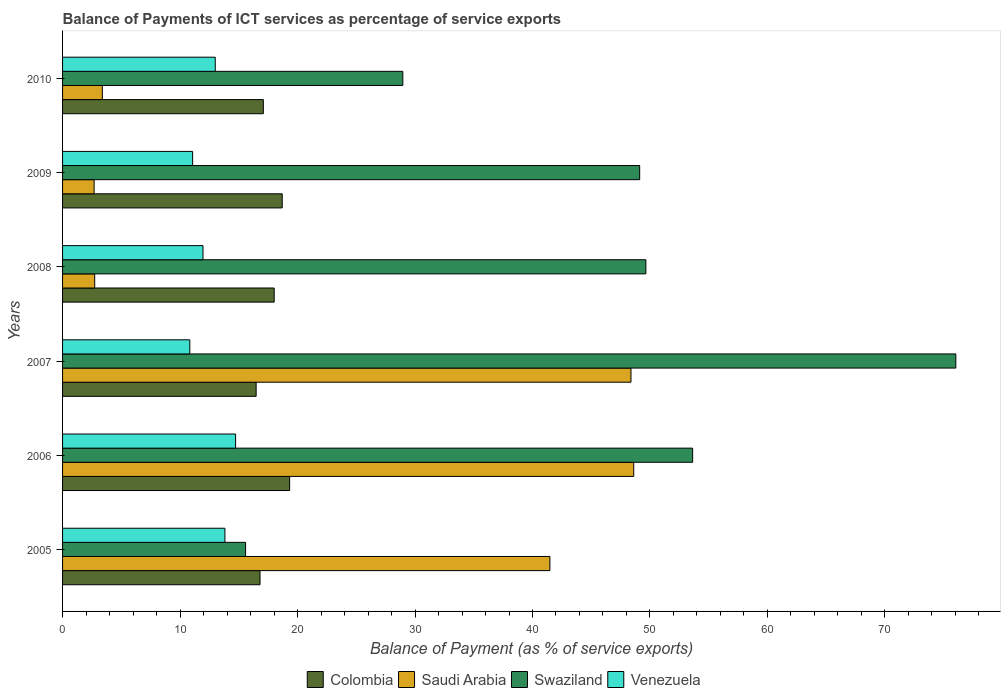How many bars are there on the 2nd tick from the bottom?
Make the answer very short. 4. In how many cases, is the number of bars for a given year not equal to the number of legend labels?
Ensure brevity in your answer.  0. What is the balance of payments of ICT services in Venezuela in 2008?
Offer a terse response. 11.95. Across all years, what is the maximum balance of payments of ICT services in Venezuela?
Keep it short and to the point. 14.73. Across all years, what is the minimum balance of payments of ICT services in Saudi Arabia?
Your answer should be compact. 2.68. What is the total balance of payments of ICT services in Saudi Arabia in the graph?
Give a very brief answer. 147.29. What is the difference between the balance of payments of ICT services in Swaziland in 2008 and that in 2009?
Your answer should be compact. 0.53. What is the difference between the balance of payments of ICT services in Venezuela in 2006 and the balance of payments of ICT services in Swaziland in 2005?
Your response must be concise. -0.85. What is the average balance of payments of ICT services in Swaziland per year?
Make the answer very short. 45.5. In the year 2010, what is the difference between the balance of payments of ICT services in Saudi Arabia and balance of payments of ICT services in Venezuela?
Your response must be concise. -9.61. In how many years, is the balance of payments of ICT services in Saudi Arabia greater than 76 %?
Keep it short and to the point. 0. What is the ratio of the balance of payments of ICT services in Swaziland in 2008 to that in 2010?
Your response must be concise. 1.71. Is the difference between the balance of payments of ICT services in Saudi Arabia in 2005 and 2010 greater than the difference between the balance of payments of ICT services in Venezuela in 2005 and 2010?
Your response must be concise. Yes. What is the difference between the highest and the second highest balance of payments of ICT services in Colombia?
Provide a succinct answer. 0.63. What is the difference between the highest and the lowest balance of payments of ICT services in Colombia?
Keep it short and to the point. 2.85. Is it the case that in every year, the sum of the balance of payments of ICT services in Swaziland and balance of payments of ICT services in Venezuela is greater than the sum of balance of payments of ICT services in Colombia and balance of payments of ICT services in Saudi Arabia?
Provide a short and direct response. Yes. What does the 2nd bar from the top in 2008 represents?
Your answer should be very brief. Swaziland. What does the 3rd bar from the bottom in 2010 represents?
Offer a terse response. Swaziland. How many bars are there?
Make the answer very short. 24. Are all the bars in the graph horizontal?
Your answer should be compact. Yes. What is the difference between two consecutive major ticks on the X-axis?
Your response must be concise. 10. Are the values on the major ticks of X-axis written in scientific E-notation?
Provide a succinct answer. No. How are the legend labels stacked?
Your answer should be very brief. Horizontal. What is the title of the graph?
Offer a terse response. Balance of Payments of ICT services as percentage of service exports. Does "Vietnam" appear as one of the legend labels in the graph?
Keep it short and to the point. No. What is the label or title of the X-axis?
Offer a very short reply. Balance of Payment (as % of service exports). What is the label or title of the Y-axis?
Keep it short and to the point. Years. What is the Balance of Payment (as % of service exports) in Colombia in 2005?
Offer a terse response. 16.81. What is the Balance of Payment (as % of service exports) of Saudi Arabia in 2005?
Your answer should be very brief. 41.48. What is the Balance of Payment (as % of service exports) in Swaziland in 2005?
Keep it short and to the point. 15.58. What is the Balance of Payment (as % of service exports) in Venezuela in 2005?
Your answer should be very brief. 13.82. What is the Balance of Payment (as % of service exports) of Colombia in 2006?
Your answer should be very brief. 19.33. What is the Balance of Payment (as % of service exports) of Saudi Arabia in 2006?
Offer a terse response. 48.62. What is the Balance of Payment (as % of service exports) in Swaziland in 2006?
Give a very brief answer. 53.63. What is the Balance of Payment (as % of service exports) in Venezuela in 2006?
Keep it short and to the point. 14.73. What is the Balance of Payment (as % of service exports) of Colombia in 2007?
Give a very brief answer. 16.48. What is the Balance of Payment (as % of service exports) of Saudi Arabia in 2007?
Provide a succinct answer. 48.38. What is the Balance of Payment (as % of service exports) of Swaziland in 2007?
Make the answer very short. 76.03. What is the Balance of Payment (as % of service exports) of Venezuela in 2007?
Make the answer very short. 10.83. What is the Balance of Payment (as % of service exports) of Colombia in 2008?
Your answer should be compact. 18.01. What is the Balance of Payment (as % of service exports) of Saudi Arabia in 2008?
Ensure brevity in your answer.  2.73. What is the Balance of Payment (as % of service exports) of Swaziland in 2008?
Ensure brevity in your answer.  49.65. What is the Balance of Payment (as % of service exports) of Venezuela in 2008?
Provide a succinct answer. 11.95. What is the Balance of Payment (as % of service exports) in Colombia in 2009?
Your response must be concise. 18.7. What is the Balance of Payment (as % of service exports) of Saudi Arabia in 2009?
Ensure brevity in your answer.  2.68. What is the Balance of Payment (as % of service exports) in Swaziland in 2009?
Give a very brief answer. 49.12. What is the Balance of Payment (as % of service exports) of Venezuela in 2009?
Make the answer very short. 11.07. What is the Balance of Payment (as % of service exports) in Colombia in 2010?
Provide a succinct answer. 17.09. What is the Balance of Payment (as % of service exports) in Saudi Arabia in 2010?
Provide a short and direct response. 3.39. What is the Balance of Payment (as % of service exports) in Swaziland in 2010?
Your response must be concise. 28.96. What is the Balance of Payment (as % of service exports) in Venezuela in 2010?
Keep it short and to the point. 13. Across all years, what is the maximum Balance of Payment (as % of service exports) of Colombia?
Provide a succinct answer. 19.33. Across all years, what is the maximum Balance of Payment (as % of service exports) of Saudi Arabia?
Provide a short and direct response. 48.62. Across all years, what is the maximum Balance of Payment (as % of service exports) in Swaziland?
Offer a very short reply. 76.03. Across all years, what is the maximum Balance of Payment (as % of service exports) of Venezuela?
Provide a succinct answer. 14.73. Across all years, what is the minimum Balance of Payment (as % of service exports) of Colombia?
Your answer should be very brief. 16.48. Across all years, what is the minimum Balance of Payment (as % of service exports) of Saudi Arabia?
Give a very brief answer. 2.68. Across all years, what is the minimum Balance of Payment (as % of service exports) of Swaziland?
Your response must be concise. 15.58. Across all years, what is the minimum Balance of Payment (as % of service exports) of Venezuela?
Your answer should be very brief. 10.83. What is the total Balance of Payment (as % of service exports) in Colombia in the graph?
Offer a terse response. 106.41. What is the total Balance of Payment (as % of service exports) in Saudi Arabia in the graph?
Keep it short and to the point. 147.29. What is the total Balance of Payment (as % of service exports) in Swaziland in the graph?
Ensure brevity in your answer.  272.98. What is the total Balance of Payment (as % of service exports) in Venezuela in the graph?
Your response must be concise. 75.4. What is the difference between the Balance of Payment (as % of service exports) of Colombia in 2005 and that in 2006?
Provide a short and direct response. -2.52. What is the difference between the Balance of Payment (as % of service exports) in Saudi Arabia in 2005 and that in 2006?
Your response must be concise. -7.14. What is the difference between the Balance of Payment (as % of service exports) of Swaziland in 2005 and that in 2006?
Offer a terse response. -38.05. What is the difference between the Balance of Payment (as % of service exports) of Venezuela in 2005 and that in 2006?
Your answer should be compact. -0.91. What is the difference between the Balance of Payment (as % of service exports) of Colombia in 2005 and that in 2007?
Your answer should be very brief. 0.33. What is the difference between the Balance of Payment (as % of service exports) of Saudi Arabia in 2005 and that in 2007?
Provide a succinct answer. -6.9. What is the difference between the Balance of Payment (as % of service exports) of Swaziland in 2005 and that in 2007?
Your answer should be very brief. -60.46. What is the difference between the Balance of Payment (as % of service exports) in Venezuela in 2005 and that in 2007?
Your response must be concise. 2.99. What is the difference between the Balance of Payment (as % of service exports) of Colombia in 2005 and that in 2008?
Ensure brevity in your answer.  -1.21. What is the difference between the Balance of Payment (as % of service exports) of Saudi Arabia in 2005 and that in 2008?
Ensure brevity in your answer.  38.75. What is the difference between the Balance of Payment (as % of service exports) of Swaziland in 2005 and that in 2008?
Make the answer very short. -34.07. What is the difference between the Balance of Payment (as % of service exports) of Venezuela in 2005 and that in 2008?
Provide a succinct answer. 1.86. What is the difference between the Balance of Payment (as % of service exports) of Colombia in 2005 and that in 2009?
Offer a terse response. -1.89. What is the difference between the Balance of Payment (as % of service exports) in Saudi Arabia in 2005 and that in 2009?
Keep it short and to the point. 38.8. What is the difference between the Balance of Payment (as % of service exports) of Swaziland in 2005 and that in 2009?
Keep it short and to the point. -33.55. What is the difference between the Balance of Payment (as % of service exports) in Venezuela in 2005 and that in 2009?
Your response must be concise. 2.75. What is the difference between the Balance of Payment (as % of service exports) of Colombia in 2005 and that in 2010?
Provide a succinct answer. -0.28. What is the difference between the Balance of Payment (as % of service exports) in Saudi Arabia in 2005 and that in 2010?
Provide a short and direct response. 38.1. What is the difference between the Balance of Payment (as % of service exports) in Swaziland in 2005 and that in 2010?
Provide a short and direct response. -13.38. What is the difference between the Balance of Payment (as % of service exports) in Venezuela in 2005 and that in 2010?
Your answer should be very brief. 0.82. What is the difference between the Balance of Payment (as % of service exports) of Colombia in 2006 and that in 2007?
Your answer should be very brief. 2.85. What is the difference between the Balance of Payment (as % of service exports) of Saudi Arabia in 2006 and that in 2007?
Offer a terse response. 0.24. What is the difference between the Balance of Payment (as % of service exports) of Swaziland in 2006 and that in 2007?
Ensure brevity in your answer.  -22.4. What is the difference between the Balance of Payment (as % of service exports) in Venezuela in 2006 and that in 2007?
Provide a short and direct response. 3.9. What is the difference between the Balance of Payment (as % of service exports) of Colombia in 2006 and that in 2008?
Provide a short and direct response. 1.32. What is the difference between the Balance of Payment (as % of service exports) in Saudi Arabia in 2006 and that in 2008?
Keep it short and to the point. 45.88. What is the difference between the Balance of Payment (as % of service exports) in Swaziland in 2006 and that in 2008?
Your answer should be compact. 3.98. What is the difference between the Balance of Payment (as % of service exports) of Venezuela in 2006 and that in 2008?
Give a very brief answer. 2.77. What is the difference between the Balance of Payment (as % of service exports) of Colombia in 2006 and that in 2009?
Provide a succinct answer. 0.63. What is the difference between the Balance of Payment (as % of service exports) of Saudi Arabia in 2006 and that in 2009?
Offer a very short reply. 45.93. What is the difference between the Balance of Payment (as % of service exports) of Swaziland in 2006 and that in 2009?
Your answer should be very brief. 4.51. What is the difference between the Balance of Payment (as % of service exports) of Venezuela in 2006 and that in 2009?
Ensure brevity in your answer.  3.66. What is the difference between the Balance of Payment (as % of service exports) in Colombia in 2006 and that in 2010?
Provide a succinct answer. 2.24. What is the difference between the Balance of Payment (as % of service exports) in Saudi Arabia in 2006 and that in 2010?
Make the answer very short. 45.23. What is the difference between the Balance of Payment (as % of service exports) of Swaziland in 2006 and that in 2010?
Make the answer very short. 24.67. What is the difference between the Balance of Payment (as % of service exports) of Venezuela in 2006 and that in 2010?
Keep it short and to the point. 1.73. What is the difference between the Balance of Payment (as % of service exports) of Colombia in 2007 and that in 2008?
Offer a very short reply. -1.54. What is the difference between the Balance of Payment (as % of service exports) of Saudi Arabia in 2007 and that in 2008?
Give a very brief answer. 45.65. What is the difference between the Balance of Payment (as % of service exports) in Swaziland in 2007 and that in 2008?
Provide a succinct answer. 26.38. What is the difference between the Balance of Payment (as % of service exports) of Venezuela in 2007 and that in 2008?
Make the answer very short. -1.12. What is the difference between the Balance of Payment (as % of service exports) in Colombia in 2007 and that in 2009?
Your response must be concise. -2.22. What is the difference between the Balance of Payment (as % of service exports) of Saudi Arabia in 2007 and that in 2009?
Offer a very short reply. 45.7. What is the difference between the Balance of Payment (as % of service exports) of Swaziland in 2007 and that in 2009?
Your answer should be compact. 26.91. What is the difference between the Balance of Payment (as % of service exports) of Venezuela in 2007 and that in 2009?
Your answer should be very brief. -0.24. What is the difference between the Balance of Payment (as % of service exports) in Colombia in 2007 and that in 2010?
Your answer should be compact. -0.61. What is the difference between the Balance of Payment (as % of service exports) of Saudi Arabia in 2007 and that in 2010?
Ensure brevity in your answer.  45. What is the difference between the Balance of Payment (as % of service exports) of Swaziland in 2007 and that in 2010?
Your response must be concise. 47.07. What is the difference between the Balance of Payment (as % of service exports) in Venezuela in 2007 and that in 2010?
Your response must be concise. -2.17. What is the difference between the Balance of Payment (as % of service exports) of Colombia in 2008 and that in 2009?
Keep it short and to the point. -0.68. What is the difference between the Balance of Payment (as % of service exports) of Saudi Arabia in 2008 and that in 2009?
Make the answer very short. 0.05. What is the difference between the Balance of Payment (as % of service exports) in Swaziland in 2008 and that in 2009?
Provide a short and direct response. 0.53. What is the difference between the Balance of Payment (as % of service exports) of Venezuela in 2008 and that in 2009?
Offer a very short reply. 0.88. What is the difference between the Balance of Payment (as % of service exports) in Colombia in 2008 and that in 2010?
Give a very brief answer. 0.93. What is the difference between the Balance of Payment (as % of service exports) in Saudi Arabia in 2008 and that in 2010?
Ensure brevity in your answer.  -0.65. What is the difference between the Balance of Payment (as % of service exports) of Swaziland in 2008 and that in 2010?
Keep it short and to the point. 20.69. What is the difference between the Balance of Payment (as % of service exports) of Venezuela in 2008 and that in 2010?
Make the answer very short. -1.04. What is the difference between the Balance of Payment (as % of service exports) of Colombia in 2009 and that in 2010?
Your answer should be very brief. 1.61. What is the difference between the Balance of Payment (as % of service exports) in Saudi Arabia in 2009 and that in 2010?
Make the answer very short. -0.7. What is the difference between the Balance of Payment (as % of service exports) of Swaziland in 2009 and that in 2010?
Ensure brevity in your answer.  20.16. What is the difference between the Balance of Payment (as % of service exports) of Venezuela in 2009 and that in 2010?
Your response must be concise. -1.93. What is the difference between the Balance of Payment (as % of service exports) in Colombia in 2005 and the Balance of Payment (as % of service exports) in Saudi Arabia in 2006?
Your answer should be compact. -31.81. What is the difference between the Balance of Payment (as % of service exports) of Colombia in 2005 and the Balance of Payment (as % of service exports) of Swaziland in 2006?
Make the answer very short. -36.82. What is the difference between the Balance of Payment (as % of service exports) of Colombia in 2005 and the Balance of Payment (as % of service exports) of Venezuela in 2006?
Make the answer very short. 2.08. What is the difference between the Balance of Payment (as % of service exports) of Saudi Arabia in 2005 and the Balance of Payment (as % of service exports) of Swaziland in 2006?
Give a very brief answer. -12.15. What is the difference between the Balance of Payment (as % of service exports) in Saudi Arabia in 2005 and the Balance of Payment (as % of service exports) in Venezuela in 2006?
Provide a short and direct response. 26.75. What is the difference between the Balance of Payment (as % of service exports) of Colombia in 2005 and the Balance of Payment (as % of service exports) of Saudi Arabia in 2007?
Keep it short and to the point. -31.57. What is the difference between the Balance of Payment (as % of service exports) of Colombia in 2005 and the Balance of Payment (as % of service exports) of Swaziland in 2007?
Keep it short and to the point. -59.23. What is the difference between the Balance of Payment (as % of service exports) of Colombia in 2005 and the Balance of Payment (as % of service exports) of Venezuela in 2007?
Ensure brevity in your answer.  5.98. What is the difference between the Balance of Payment (as % of service exports) of Saudi Arabia in 2005 and the Balance of Payment (as % of service exports) of Swaziland in 2007?
Your answer should be very brief. -34.55. What is the difference between the Balance of Payment (as % of service exports) of Saudi Arabia in 2005 and the Balance of Payment (as % of service exports) of Venezuela in 2007?
Your answer should be very brief. 30.65. What is the difference between the Balance of Payment (as % of service exports) of Swaziland in 2005 and the Balance of Payment (as % of service exports) of Venezuela in 2007?
Your answer should be compact. 4.75. What is the difference between the Balance of Payment (as % of service exports) in Colombia in 2005 and the Balance of Payment (as % of service exports) in Saudi Arabia in 2008?
Your answer should be very brief. 14.07. What is the difference between the Balance of Payment (as % of service exports) of Colombia in 2005 and the Balance of Payment (as % of service exports) of Swaziland in 2008?
Provide a succinct answer. -32.84. What is the difference between the Balance of Payment (as % of service exports) in Colombia in 2005 and the Balance of Payment (as % of service exports) in Venezuela in 2008?
Provide a short and direct response. 4.85. What is the difference between the Balance of Payment (as % of service exports) of Saudi Arabia in 2005 and the Balance of Payment (as % of service exports) of Swaziland in 2008?
Your response must be concise. -8.17. What is the difference between the Balance of Payment (as % of service exports) of Saudi Arabia in 2005 and the Balance of Payment (as % of service exports) of Venezuela in 2008?
Your answer should be compact. 29.53. What is the difference between the Balance of Payment (as % of service exports) in Swaziland in 2005 and the Balance of Payment (as % of service exports) in Venezuela in 2008?
Provide a short and direct response. 3.62. What is the difference between the Balance of Payment (as % of service exports) of Colombia in 2005 and the Balance of Payment (as % of service exports) of Saudi Arabia in 2009?
Provide a short and direct response. 14.12. What is the difference between the Balance of Payment (as % of service exports) of Colombia in 2005 and the Balance of Payment (as % of service exports) of Swaziland in 2009?
Give a very brief answer. -32.32. What is the difference between the Balance of Payment (as % of service exports) of Colombia in 2005 and the Balance of Payment (as % of service exports) of Venezuela in 2009?
Make the answer very short. 5.74. What is the difference between the Balance of Payment (as % of service exports) of Saudi Arabia in 2005 and the Balance of Payment (as % of service exports) of Swaziland in 2009?
Ensure brevity in your answer.  -7.64. What is the difference between the Balance of Payment (as % of service exports) in Saudi Arabia in 2005 and the Balance of Payment (as % of service exports) in Venezuela in 2009?
Your answer should be compact. 30.41. What is the difference between the Balance of Payment (as % of service exports) of Swaziland in 2005 and the Balance of Payment (as % of service exports) of Venezuela in 2009?
Ensure brevity in your answer.  4.51. What is the difference between the Balance of Payment (as % of service exports) in Colombia in 2005 and the Balance of Payment (as % of service exports) in Saudi Arabia in 2010?
Your answer should be very brief. 13.42. What is the difference between the Balance of Payment (as % of service exports) in Colombia in 2005 and the Balance of Payment (as % of service exports) in Swaziland in 2010?
Offer a very short reply. -12.16. What is the difference between the Balance of Payment (as % of service exports) of Colombia in 2005 and the Balance of Payment (as % of service exports) of Venezuela in 2010?
Your response must be concise. 3.81. What is the difference between the Balance of Payment (as % of service exports) in Saudi Arabia in 2005 and the Balance of Payment (as % of service exports) in Swaziland in 2010?
Give a very brief answer. 12.52. What is the difference between the Balance of Payment (as % of service exports) in Saudi Arabia in 2005 and the Balance of Payment (as % of service exports) in Venezuela in 2010?
Your response must be concise. 28.48. What is the difference between the Balance of Payment (as % of service exports) in Swaziland in 2005 and the Balance of Payment (as % of service exports) in Venezuela in 2010?
Offer a terse response. 2.58. What is the difference between the Balance of Payment (as % of service exports) of Colombia in 2006 and the Balance of Payment (as % of service exports) of Saudi Arabia in 2007?
Offer a very short reply. -29.05. What is the difference between the Balance of Payment (as % of service exports) in Colombia in 2006 and the Balance of Payment (as % of service exports) in Swaziland in 2007?
Keep it short and to the point. -56.71. What is the difference between the Balance of Payment (as % of service exports) in Colombia in 2006 and the Balance of Payment (as % of service exports) in Venezuela in 2007?
Offer a terse response. 8.5. What is the difference between the Balance of Payment (as % of service exports) of Saudi Arabia in 2006 and the Balance of Payment (as % of service exports) of Swaziland in 2007?
Your response must be concise. -27.42. What is the difference between the Balance of Payment (as % of service exports) in Saudi Arabia in 2006 and the Balance of Payment (as % of service exports) in Venezuela in 2007?
Your answer should be very brief. 37.79. What is the difference between the Balance of Payment (as % of service exports) of Swaziland in 2006 and the Balance of Payment (as % of service exports) of Venezuela in 2007?
Provide a short and direct response. 42.8. What is the difference between the Balance of Payment (as % of service exports) in Colombia in 2006 and the Balance of Payment (as % of service exports) in Saudi Arabia in 2008?
Make the answer very short. 16.59. What is the difference between the Balance of Payment (as % of service exports) of Colombia in 2006 and the Balance of Payment (as % of service exports) of Swaziland in 2008?
Make the answer very short. -30.32. What is the difference between the Balance of Payment (as % of service exports) of Colombia in 2006 and the Balance of Payment (as % of service exports) of Venezuela in 2008?
Ensure brevity in your answer.  7.37. What is the difference between the Balance of Payment (as % of service exports) in Saudi Arabia in 2006 and the Balance of Payment (as % of service exports) in Swaziland in 2008?
Your response must be concise. -1.03. What is the difference between the Balance of Payment (as % of service exports) of Saudi Arabia in 2006 and the Balance of Payment (as % of service exports) of Venezuela in 2008?
Provide a short and direct response. 36.66. What is the difference between the Balance of Payment (as % of service exports) in Swaziland in 2006 and the Balance of Payment (as % of service exports) in Venezuela in 2008?
Offer a terse response. 41.68. What is the difference between the Balance of Payment (as % of service exports) of Colombia in 2006 and the Balance of Payment (as % of service exports) of Saudi Arabia in 2009?
Your answer should be very brief. 16.64. What is the difference between the Balance of Payment (as % of service exports) of Colombia in 2006 and the Balance of Payment (as % of service exports) of Swaziland in 2009?
Keep it short and to the point. -29.8. What is the difference between the Balance of Payment (as % of service exports) in Colombia in 2006 and the Balance of Payment (as % of service exports) in Venezuela in 2009?
Make the answer very short. 8.26. What is the difference between the Balance of Payment (as % of service exports) of Saudi Arabia in 2006 and the Balance of Payment (as % of service exports) of Swaziland in 2009?
Make the answer very short. -0.51. What is the difference between the Balance of Payment (as % of service exports) of Saudi Arabia in 2006 and the Balance of Payment (as % of service exports) of Venezuela in 2009?
Your answer should be compact. 37.55. What is the difference between the Balance of Payment (as % of service exports) in Swaziland in 2006 and the Balance of Payment (as % of service exports) in Venezuela in 2009?
Offer a terse response. 42.56. What is the difference between the Balance of Payment (as % of service exports) in Colombia in 2006 and the Balance of Payment (as % of service exports) in Saudi Arabia in 2010?
Offer a terse response. 15.94. What is the difference between the Balance of Payment (as % of service exports) in Colombia in 2006 and the Balance of Payment (as % of service exports) in Swaziland in 2010?
Your answer should be very brief. -9.63. What is the difference between the Balance of Payment (as % of service exports) of Colombia in 2006 and the Balance of Payment (as % of service exports) of Venezuela in 2010?
Your answer should be compact. 6.33. What is the difference between the Balance of Payment (as % of service exports) of Saudi Arabia in 2006 and the Balance of Payment (as % of service exports) of Swaziland in 2010?
Ensure brevity in your answer.  19.65. What is the difference between the Balance of Payment (as % of service exports) of Saudi Arabia in 2006 and the Balance of Payment (as % of service exports) of Venezuela in 2010?
Provide a succinct answer. 35.62. What is the difference between the Balance of Payment (as % of service exports) of Swaziland in 2006 and the Balance of Payment (as % of service exports) of Venezuela in 2010?
Keep it short and to the point. 40.63. What is the difference between the Balance of Payment (as % of service exports) of Colombia in 2007 and the Balance of Payment (as % of service exports) of Saudi Arabia in 2008?
Your answer should be compact. 13.74. What is the difference between the Balance of Payment (as % of service exports) in Colombia in 2007 and the Balance of Payment (as % of service exports) in Swaziland in 2008?
Your answer should be compact. -33.17. What is the difference between the Balance of Payment (as % of service exports) in Colombia in 2007 and the Balance of Payment (as % of service exports) in Venezuela in 2008?
Offer a terse response. 4.52. What is the difference between the Balance of Payment (as % of service exports) in Saudi Arabia in 2007 and the Balance of Payment (as % of service exports) in Swaziland in 2008?
Your response must be concise. -1.27. What is the difference between the Balance of Payment (as % of service exports) of Saudi Arabia in 2007 and the Balance of Payment (as % of service exports) of Venezuela in 2008?
Provide a succinct answer. 36.43. What is the difference between the Balance of Payment (as % of service exports) of Swaziland in 2007 and the Balance of Payment (as % of service exports) of Venezuela in 2008?
Provide a short and direct response. 64.08. What is the difference between the Balance of Payment (as % of service exports) of Colombia in 2007 and the Balance of Payment (as % of service exports) of Saudi Arabia in 2009?
Your response must be concise. 13.79. What is the difference between the Balance of Payment (as % of service exports) of Colombia in 2007 and the Balance of Payment (as % of service exports) of Swaziland in 2009?
Provide a short and direct response. -32.65. What is the difference between the Balance of Payment (as % of service exports) of Colombia in 2007 and the Balance of Payment (as % of service exports) of Venezuela in 2009?
Your response must be concise. 5.41. What is the difference between the Balance of Payment (as % of service exports) in Saudi Arabia in 2007 and the Balance of Payment (as % of service exports) in Swaziland in 2009?
Ensure brevity in your answer.  -0.74. What is the difference between the Balance of Payment (as % of service exports) in Saudi Arabia in 2007 and the Balance of Payment (as % of service exports) in Venezuela in 2009?
Your response must be concise. 37.31. What is the difference between the Balance of Payment (as % of service exports) of Swaziland in 2007 and the Balance of Payment (as % of service exports) of Venezuela in 2009?
Provide a short and direct response. 64.96. What is the difference between the Balance of Payment (as % of service exports) of Colombia in 2007 and the Balance of Payment (as % of service exports) of Saudi Arabia in 2010?
Your response must be concise. 13.09. What is the difference between the Balance of Payment (as % of service exports) in Colombia in 2007 and the Balance of Payment (as % of service exports) in Swaziland in 2010?
Your response must be concise. -12.49. What is the difference between the Balance of Payment (as % of service exports) of Colombia in 2007 and the Balance of Payment (as % of service exports) of Venezuela in 2010?
Keep it short and to the point. 3.48. What is the difference between the Balance of Payment (as % of service exports) in Saudi Arabia in 2007 and the Balance of Payment (as % of service exports) in Swaziland in 2010?
Keep it short and to the point. 19.42. What is the difference between the Balance of Payment (as % of service exports) of Saudi Arabia in 2007 and the Balance of Payment (as % of service exports) of Venezuela in 2010?
Provide a short and direct response. 35.39. What is the difference between the Balance of Payment (as % of service exports) in Swaziland in 2007 and the Balance of Payment (as % of service exports) in Venezuela in 2010?
Your response must be concise. 63.04. What is the difference between the Balance of Payment (as % of service exports) in Colombia in 2008 and the Balance of Payment (as % of service exports) in Saudi Arabia in 2009?
Your answer should be compact. 15.33. What is the difference between the Balance of Payment (as % of service exports) in Colombia in 2008 and the Balance of Payment (as % of service exports) in Swaziland in 2009?
Provide a short and direct response. -31.11. What is the difference between the Balance of Payment (as % of service exports) of Colombia in 2008 and the Balance of Payment (as % of service exports) of Venezuela in 2009?
Your answer should be very brief. 6.94. What is the difference between the Balance of Payment (as % of service exports) of Saudi Arabia in 2008 and the Balance of Payment (as % of service exports) of Swaziland in 2009?
Your answer should be very brief. -46.39. What is the difference between the Balance of Payment (as % of service exports) in Saudi Arabia in 2008 and the Balance of Payment (as % of service exports) in Venezuela in 2009?
Your answer should be very brief. -8.34. What is the difference between the Balance of Payment (as % of service exports) in Swaziland in 2008 and the Balance of Payment (as % of service exports) in Venezuela in 2009?
Offer a very short reply. 38.58. What is the difference between the Balance of Payment (as % of service exports) in Colombia in 2008 and the Balance of Payment (as % of service exports) in Saudi Arabia in 2010?
Offer a very short reply. 14.63. What is the difference between the Balance of Payment (as % of service exports) in Colombia in 2008 and the Balance of Payment (as % of service exports) in Swaziland in 2010?
Ensure brevity in your answer.  -10.95. What is the difference between the Balance of Payment (as % of service exports) of Colombia in 2008 and the Balance of Payment (as % of service exports) of Venezuela in 2010?
Make the answer very short. 5.02. What is the difference between the Balance of Payment (as % of service exports) in Saudi Arabia in 2008 and the Balance of Payment (as % of service exports) in Swaziland in 2010?
Your answer should be compact. -26.23. What is the difference between the Balance of Payment (as % of service exports) of Saudi Arabia in 2008 and the Balance of Payment (as % of service exports) of Venezuela in 2010?
Your answer should be compact. -10.26. What is the difference between the Balance of Payment (as % of service exports) of Swaziland in 2008 and the Balance of Payment (as % of service exports) of Venezuela in 2010?
Provide a short and direct response. 36.65. What is the difference between the Balance of Payment (as % of service exports) of Colombia in 2009 and the Balance of Payment (as % of service exports) of Saudi Arabia in 2010?
Ensure brevity in your answer.  15.31. What is the difference between the Balance of Payment (as % of service exports) of Colombia in 2009 and the Balance of Payment (as % of service exports) of Swaziland in 2010?
Offer a terse response. -10.27. What is the difference between the Balance of Payment (as % of service exports) of Colombia in 2009 and the Balance of Payment (as % of service exports) of Venezuela in 2010?
Make the answer very short. 5.7. What is the difference between the Balance of Payment (as % of service exports) of Saudi Arabia in 2009 and the Balance of Payment (as % of service exports) of Swaziland in 2010?
Keep it short and to the point. -26.28. What is the difference between the Balance of Payment (as % of service exports) of Saudi Arabia in 2009 and the Balance of Payment (as % of service exports) of Venezuela in 2010?
Your answer should be very brief. -10.31. What is the difference between the Balance of Payment (as % of service exports) of Swaziland in 2009 and the Balance of Payment (as % of service exports) of Venezuela in 2010?
Make the answer very short. 36.13. What is the average Balance of Payment (as % of service exports) of Colombia per year?
Give a very brief answer. 17.74. What is the average Balance of Payment (as % of service exports) in Saudi Arabia per year?
Give a very brief answer. 24.55. What is the average Balance of Payment (as % of service exports) of Swaziland per year?
Offer a very short reply. 45.5. What is the average Balance of Payment (as % of service exports) in Venezuela per year?
Make the answer very short. 12.57. In the year 2005, what is the difference between the Balance of Payment (as % of service exports) of Colombia and Balance of Payment (as % of service exports) of Saudi Arabia?
Provide a short and direct response. -24.67. In the year 2005, what is the difference between the Balance of Payment (as % of service exports) in Colombia and Balance of Payment (as % of service exports) in Swaziland?
Provide a short and direct response. 1.23. In the year 2005, what is the difference between the Balance of Payment (as % of service exports) in Colombia and Balance of Payment (as % of service exports) in Venezuela?
Your answer should be compact. 2.99. In the year 2005, what is the difference between the Balance of Payment (as % of service exports) in Saudi Arabia and Balance of Payment (as % of service exports) in Swaziland?
Keep it short and to the point. 25.9. In the year 2005, what is the difference between the Balance of Payment (as % of service exports) of Saudi Arabia and Balance of Payment (as % of service exports) of Venezuela?
Provide a succinct answer. 27.66. In the year 2005, what is the difference between the Balance of Payment (as % of service exports) of Swaziland and Balance of Payment (as % of service exports) of Venezuela?
Provide a succinct answer. 1.76. In the year 2006, what is the difference between the Balance of Payment (as % of service exports) in Colombia and Balance of Payment (as % of service exports) in Saudi Arabia?
Provide a short and direct response. -29.29. In the year 2006, what is the difference between the Balance of Payment (as % of service exports) in Colombia and Balance of Payment (as % of service exports) in Swaziland?
Ensure brevity in your answer.  -34.3. In the year 2006, what is the difference between the Balance of Payment (as % of service exports) in Saudi Arabia and Balance of Payment (as % of service exports) in Swaziland?
Provide a succinct answer. -5.01. In the year 2006, what is the difference between the Balance of Payment (as % of service exports) of Saudi Arabia and Balance of Payment (as % of service exports) of Venezuela?
Offer a terse response. 33.89. In the year 2006, what is the difference between the Balance of Payment (as % of service exports) of Swaziland and Balance of Payment (as % of service exports) of Venezuela?
Your answer should be very brief. 38.9. In the year 2007, what is the difference between the Balance of Payment (as % of service exports) of Colombia and Balance of Payment (as % of service exports) of Saudi Arabia?
Provide a short and direct response. -31.9. In the year 2007, what is the difference between the Balance of Payment (as % of service exports) in Colombia and Balance of Payment (as % of service exports) in Swaziland?
Your answer should be compact. -59.56. In the year 2007, what is the difference between the Balance of Payment (as % of service exports) of Colombia and Balance of Payment (as % of service exports) of Venezuela?
Your answer should be very brief. 5.65. In the year 2007, what is the difference between the Balance of Payment (as % of service exports) in Saudi Arabia and Balance of Payment (as % of service exports) in Swaziland?
Provide a succinct answer. -27.65. In the year 2007, what is the difference between the Balance of Payment (as % of service exports) in Saudi Arabia and Balance of Payment (as % of service exports) in Venezuela?
Your response must be concise. 37.55. In the year 2007, what is the difference between the Balance of Payment (as % of service exports) in Swaziland and Balance of Payment (as % of service exports) in Venezuela?
Provide a succinct answer. 65.2. In the year 2008, what is the difference between the Balance of Payment (as % of service exports) of Colombia and Balance of Payment (as % of service exports) of Saudi Arabia?
Give a very brief answer. 15.28. In the year 2008, what is the difference between the Balance of Payment (as % of service exports) in Colombia and Balance of Payment (as % of service exports) in Swaziland?
Provide a succinct answer. -31.64. In the year 2008, what is the difference between the Balance of Payment (as % of service exports) of Colombia and Balance of Payment (as % of service exports) of Venezuela?
Ensure brevity in your answer.  6.06. In the year 2008, what is the difference between the Balance of Payment (as % of service exports) in Saudi Arabia and Balance of Payment (as % of service exports) in Swaziland?
Provide a succinct answer. -46.92. In the year 2008, what is the difference between the Balance of Payment (as % of service exports) in Saudi Arabia and Balance of Payment (as % of service exports) in Venezuela?
Your response must be concise. -9.22. In the year 2008, what is the difference between the Balance of Payment (as % of service exports) in Swaziland and Balance of Payment (as % of service exports) in Venezuela?
Give a very brief answer. 37.7. In the year 2009, what is the difference between the Balance of Payment (as % of service exports) in Colombia and Balance of Payment (as % of service exports) in Saudi Arabia?
Ensure brevity in your answer.  16.01. In the year 2009, what is the difference between the Balance of Payment (as % of service exports) of Colombia and Balance of Payment (as % of service exports) of Swaziland?
Offer a terse response. -30.43. In the year 2009, what is the difference between the Balance of Payment (as % of service exports) of Colombia and Balance of Payment (as % of service exports) of Venezuela?
Ensure brevity in your answer.  7.63. In the year 2009, what is the difference between the Balance of Payment (as % of service exports) in Saudi Arabia and Balance of Payment (as % of service exports) in Swaziland?
Ensure brevity in your answer.  -46.44. In the year 2009, what is the difference between the Balance of Payment (as % of service exports) in Saudi Arabia and Balance of Payment (as % of service exports) in Venezuela?
Keep it short and to the point. -8.39. In the year 2009, what is the difference between the Balance of Payment (as % of service exports) in Swaziland and Balance of Payment (as % of service exports) in Venezuela?
Offer a terse response. 38.05. In the year 2010, what is the difference between the Balance of Payment (as % of service exports) of Colombia and Balance of Payment (as % of service exports) of Saudi Arabia?
Your response must be concise. 13.7. In the year 2010, what is the difference between the Balance of Payment (as % of service exports) in Colombia and Balance of Payment (as % of service exports) in Swaziland?
Ensure brevity in your answer.  -11.87. In the year 2010, what is the difference between the Balance of Payment (as % of service exports) in Colombia and Balance of Payment (as % of service exports) in Venezuela?
Your answer should be compact. 4.09. In the year 2010, what is the difference between the Balance of Payment (as % of service exports) in Saudi Arabia and Balance of Payment (as % of service exports) in Swaziland?
Your answer should be compact. -25.58. In the year 2010, what is the difference between the Balance of Payment (as % of service exports) in Saudi Arabia and Balance of Payment (as % of service exports) in Venezuela?
Your response must be concise. -9.61. In the year 2010, what is the difference between the Balance of Payment (as % of service exports) of Swaziland and Balance of Payment (as % of service exports) of Venezuela?
Provide a succinct answer. 15.97. What is the ratio of the Balance of Payment (as % of service exports) in Colombia in 2005 to that in 2006?
Offer a very short reply. 0.87. What is the ratio of the Balance of Payment (as % of service exports) of Saudi Arabia in 2005 to that in 2006?
Ensure brevity in your answer.  0.85. What is the ratio of the Balance of Payment (as % of service exports) in Swaziland in 2005 to that in 2006?
Offer a very short reply. 0.29. What is the ratio of the Balance of Payment (as % of service exports) in Venezuela in 2005 to that in 2006?
Give a very brief answer. 0.94. What is the ratio of the Balance of Payment (as % of service exports) of Colombia in 2005 to that in 2007?
Your response must be concise. 1.02. What is the ratio of the Balance of Payment (as % of service exports) of Saudi Arabia in 2005 to that in 2007?
Offer a terse response. 0.86. What is the ratio of the Balance of Payment (as % of service exports) in Swaziland in 2005 to that in 2007?
Your answer should be very brief. 0.2. What is the ratio of the Balance of Payment (as % of service exports) of Venezuela in 2005 to that in 2007?
Give a very brief answer. 1.28. What is the ratio of the Balance of Payment (as % of service exports) of Colombia in 2005 to that in 2008?
Your response must be concise. 0.93. What is the ratio of the Balance of Payment (as % of service exports) in Saudi Arabia in 2005 to that in 2008?
Offer a terse response. 15.17. What is the ratio of the Balance of Payment (as % of service exports) in Swaziland in 2005 to that in 2008?
Your response must be concise. 0.31. What is the ratio of the Balance of Payment (as % of service exports) in Venezuela in 2005 to that in 2008?
Keep it short and to the point. 1.16. What is the ratio of the Balance of Payment (as % of service exports) in Colombia in 2005 to that in 2009?
Offer a very short reply. 0.9. What is the ratio of the Balance of Payment (as % of service exports) of Saudi Arabia in 2005 to that in 2009?
Make the answer very short. 15.45. What is the ratio of the Balance of Payment (as % of service exports) in Swaziland in 2005 to that in 2009?
Offer a very short reply. 0.32. What is the ratio of the Balance of Payment (as % of service exports) in Venezuela in 2005 to that in 2009?
Offer a very short reply. 1.25. What is the ratio of the Balance of Payment (as % of service exports) in Colombia in 2005 to that in 2010?
Your response must be concise. 0.98. What is the ratio of the Balance of Payment (as % of service exports) of Saudi Arabia in 2005 to that in 2010?
Your response must be concise. 12.25. What is the ratio of the Balance of Payment (as % of service exports) of Swaziland in 2005 to that in 2010?
Your response must be concise. 0.54. What is the ratio of the Balance of Payment (as % of service exports) in Venezuela in 2005 to that in 2010?
Keep it short and to the point. 1.06. What is the ratio of the Balance of Payment (as % of service exports) in Colombia in 2006 to that in 2007?
Keep it short and to the point. 1.17. What is the ratio of the Balance of Payment (as % of service exports) of Saudi Arabia in 2006 to that in 2007?
Ensure brevity in your answer.  1. What is the ratio of the Balance of Payment (as % of service exports) in Swaziland in 2006 to that in 2007?
Offer a very short reply. 0.71. What is the ratio of the Balance of Payment (as % of service exports) in Venezuela in 2006 to that in 2007?
Offer a terse response. 1.36. What is the ratio of the Balance of Payment (as % of service exports) of Colombia in 2006 to that in 2008?
Provide a short and direct response. 1.07. What is the ratio of the Balance of Payment (as % of service exports) in Saudi Arabia in 2006 to that in 2008?
Ensure brevity in your answer.  17.78. What is the ratio of the Balance of Payment (as % of service exports) of Swaziland in 2006 to that in 2008?
Ensure brevity in your answer.  1.08. What is the ratio of the Balance of Payment (as % of service exports) in Venezuela in 2006 to that in 2008?
Make the answer very short. 1.23. What is the ratio of the Balance of Payment (as % of service exports) of Colombia in 2006 to that in 2009?
Provide a succinct answer. 1.03. What is the ratio of the Balance of Payment (as % of service exports) in Saudi Arabia in 2006 to that in 2009?
Your answer should be very brief. 18.11. What is the ratio of the Balance of Payment (as % of service exports) of Swaziland in 2006 to that in 2009?
Make the answer very short. 1.09. What is the ratio of the Balance of Payment (as % of service exports) of Venezuela in 2006 to that in 2009?
Your answer should be compact. 1.33. What is the ratio of the Balance of Payment (as % of service exports) in Colombia in 2006 to that in 2010?
Give a very brief answer. 1.13. What is the ratio of the Balance of Payment (as % of service exports) in Saudi Arabia in 2006 to that in 2010?
Make the answer very short. 14.36. What is the ratio of the Balance of Payment (as % of service exports) of Swaziland in 2006 to that in 2010?
Provide a short and direct response. 1.85. What is the ratio of the Balance of Payment (as % of service exports) of Venezuela in 2006 to that in 2010?
Offer a very short reply. 1.13. What is the ratio of the Balance of Payment (as % of service exports) in Colombia in 2007 to that in 2008?
Offer a very short reply. 0.91. What is the ratio of the Balance of Payment (as % of service exports) of Saudi Arabia in 2007 to that in 2008?
Keep it short and to the point. 17.69. What is the ratio of the Balance of Payment (as % of service exports) of Swaziland in 2007 to that in 2008?
Provide a succinct answer. 1.53. What is the ratio of the Balance of Payment (as % of service exports) of Venezuela in 2007 to that in 2008?
Offer a terse response. 0.91. What is the ratio of the Balance of Payment (as % of service exports) in Colombia in 2007 to that in 2009?
Your response must be concise. 0.88. What is the ratio of the Balance of Payment (as % of service exports) of Saudi Arabia in 2007 to that in 2009?
Provide a succinct answer. 18.02. What is the ratio of the Balance of Payment (as % of service exports) in Swaziland in 2007 to that in 2009?
Your response must be concise. 1.55. What is the ratio of the Balance of Payment (as % of service exports) in Venezuela in 2007 to that in 2009?
Make the answer very short. 0.98. What is the ratio of the Balance of Payment (as % of service exports) of Colombia in 2007 to that in 2010?
Ensure brevity in your answer.  0.96. What is the ratio of the Balance of Payment (as % of service exports) in Saudi Arabia in 2007 to that in 2010?
Keep it short and to the point. 14.29. What is the ratio of the Balance of Payment (as % of service exports) in Swaziland in 2007 to that in 2010?
Offer a terse response. 2.63. What is the ratio of the Balance of Payment (as % of service exports) of Venezuela in 2007 to that in 2010?
Give a very brief answer. 0.83. What is the ratio of the Balance of Payment (as % of service exports) of Colombia in 2008 to that in 2009?
Provide a succinct answer. 0.96. What is the ratio of the Balance of Payment (as % of service exports) in Saudi Arabia in 2008 to that in 2009?
Offer a very short reply. 1.02. What is the ratio of the Balance of Payment (as % of service exports) in Swaziland in 2008 to that in 2009?
Your answer should be very brief. 1.01. What is the ratio of the Balance of Payment (as % of service exports) of Venezuela in 2008 to that in 2009?
Provide a succinct answer. 1.08. What is the ratio of the Balance of Payment (as % of service exports) of Colombia in 2008 to that in 2010?
Give a very brief answer. 1.05. What is the ratio of the Balance of Payment (as % of service exports) of Saudi Arabia in 2008 to that in 2010?
Keep it short and to the point. 0.81. What is the ratio of the Balance of Payment (as % of service exports) of Swaziland in 2008 to that in 2010?
Ensure brevity in your answer.  1.71. What is the ratio of the Balance of Payment (as % of service exports) of Venezuela in 2008 to that in 2010?
Your answer should be compact. 0.92. What is the ratio of the Balance of Payment (as % of service exports) of Colombia in 2009 to that in 2010?
Offer a very short reply. 1.09. What is the ratio of the Balance of Payment (as % of service exports) of Saudi Arabia in 2009 to that in 2010?
Offer a very short reply. 0.79. What is the ratio of the Balance of Payment (as % of service exports) of Swaziland in 2009 to that in 2010?
Keep it short and to the point. 1.7. What is the ratio of the Balance of Payment (as % of service exports) of Venezuela in 2009 to that in 2010?
Your answer should be very brief. 0.85. What is the difference between the highest and the second highest Balance of Payment (as % of service exports) in Colombia?
Offer a very short reply. 0.63. What is the difference between the highest and the second highest Balance of Payment (as % of service exports) of Saudi Arabia?
Provide a succinct answer. 0.24. What is the difference between the highest and the second highest Balance of Payment (as % of service exports) in Swaziland?
Your response must be concise. 22.4. What is the difference between the highest and the second highest Balance of Payment (as % of service exports) of Venezuela?
Your response must be concise. 0.91. What is the difference between the highest and the lowest Balance of Payment (as % of service exports) of Colombia?
Ensure brevity in your answer.  2.85. What is the difference between the highest and the lowest Balance of Payment (as % of service exports) in Saudi Arabia?
Keep it short and to the point. 45.93. What is the difference between the highest and the lowest Balance of Payment (as % of service exports) in Swaziland?
Offer a very short reply. 60.46. What is the difference between the highest and the lowest Balance of Payment (as % of service exports) of Venezuela?
Your response must be concise. 3.9. 